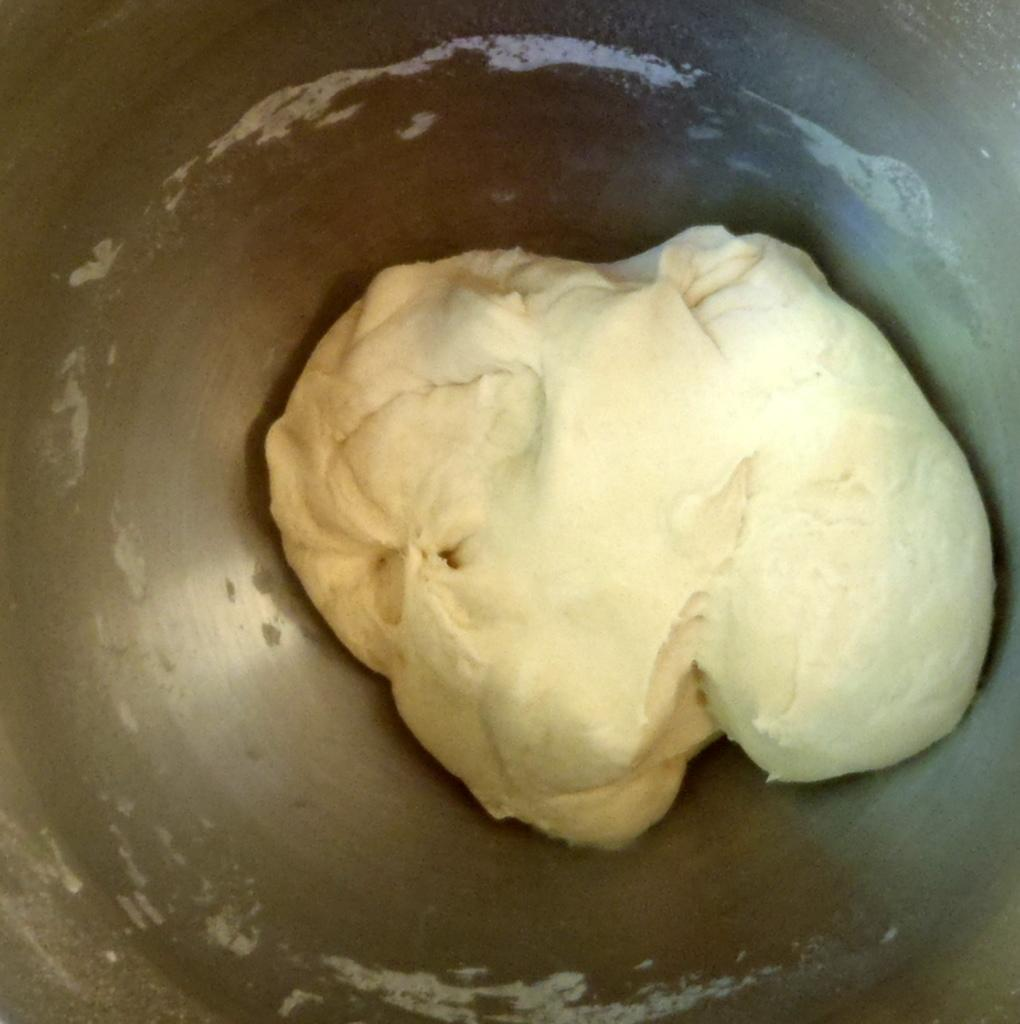What is the main subject of the image? The main subject of the image is flour dough. Where is the flour dough located? The flour dough is in a container. What type of hook can be seen hanging from the robin in the image? There is no hook or robin present in the image; it only features flour dough in a container. 